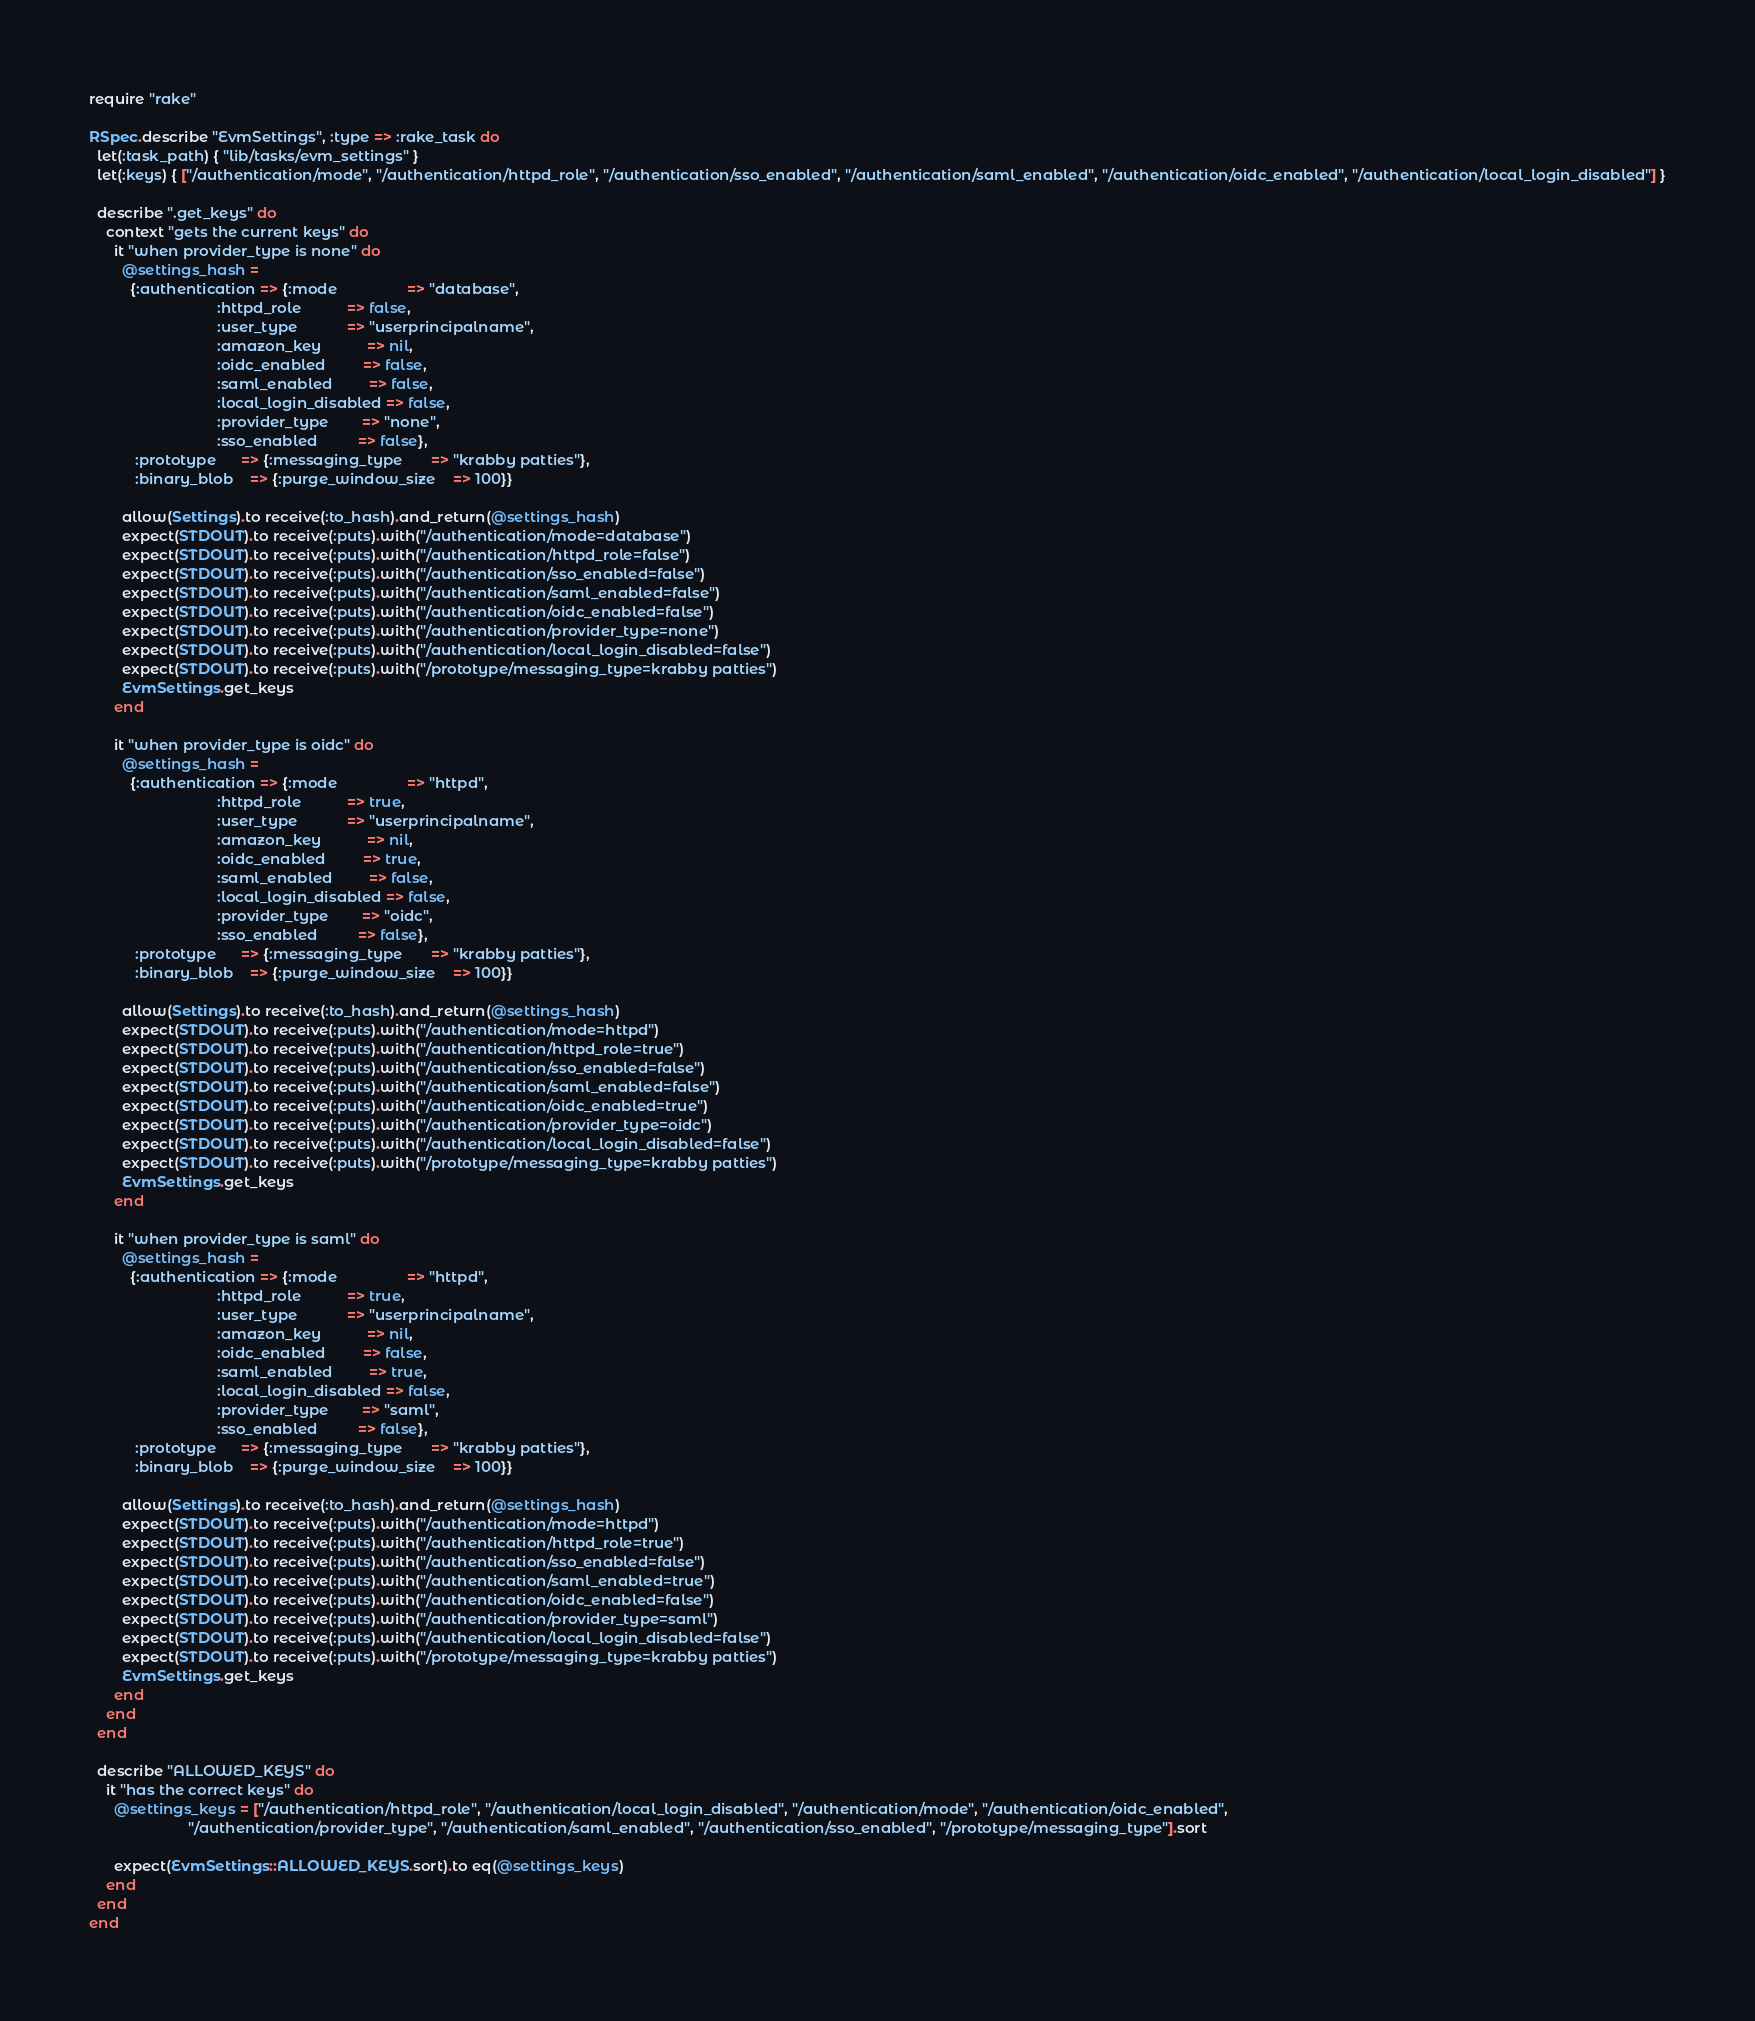Convert code to text. <code><loc_0><loc_0><loc_500><loc_500><_Ruby_>require "rake"

RSpec.describe "EvmSettings", :type => :rake_task do
  let(:task_path) { "lib/tasks/evm_settings" }
  let(:keys) { ["/authentication/mode", "/authentication/httpd_role", "/authentication/sso_enabled", "/authentication/saml_enabled", "/authentication/oidc_enabled", "/authentication/local_login_disabled"] }

  describe ".get_keys" do
    context "gets the current keys" do
      it "when provider_type is none" do
        @settings_hash =
          {:authentication => {:mode                 => "database",
                               :httpd_role           => false,
                               :user_type            => "userprincipalname",
                               :amazon_key           => nil,
                               :oidc_enabled         => false,
                               :saml_enabled         => false,
                               :local_login_disabled => false,
                               :provider_type        => "none",
                               :sso_enabled          => false},
           :prototype      => {:messaging_type       => "krabby patties"},
           :binary_blob    => {:purge_window_size    => 100}}

        allow(Settings).to receive(:to_hash).and_return(@settings_hash)
        expect(STDOUT).to receive(:puts).with("/authentication/mode=database")
        expect(STDOUT).to receive(:puts).with("/authentication/httpd_role=false")
        expect(STDOUT).to receive(:puts).with("/authentication/sso_enabled=false")
        expect(STDOUT).to receive(:puts).with("/authentication/saml_enabled=false")
        expect(STDOUT).to receive(:puts).with("/authentication/oidc_enabled=false")
        expect(STDOUT).to receive(:puts).with("/authentication/provider_type=none")
        expect(STDOUT).to receive(:puts).with("/authentication/local_login_disabled=false")
        expect(STDOUT).to receive(:puts).with("/prototype/messaging_type=krabby patties")
        EvmSettings.get_keys
      end

      it "when provider_type is oidc" do
        @settings_hash =
          {:authentication => {:mode                 => "httpd",
                               :httpd_role           => true,
                               :user_type            => "userprincipalname",
                               :amazon_key           => nil,
                               :oidc_enabled         => true,
                               :saml_enabled         => false,
                               :local_login_disabled => false,
                               :provider_type        => "oidc",
                               :sso_enabled          => false},
           :prototype      => {:messaging_type       => "krabby patties"},
           :binary_blob    => {:purge_window_size    => 100}}

        allow(Settings).to receive(:to_hash).and_return(@settings_hash)
        expect(STDOUT).to receive(:puts).with("/authentication/mode=httpd")
        expect(STDOUT).to receive(:puts).with("/authentication/httpd_role=true")
        expect(STDOUT).to receive(:puts).with("/authentication/sso_enabled=false")
        expect(STDOUT).to receive(:puts).with("/authentication/saml_enabled=false")
        expect(STDOUT).to receive(:puts).with("/authentication/oidc_enabled=true")
        expect(STDOUT).to receive(:puts).with("/authentication/provider_type=oidc")
        expect(STDOUT).to receive(:puts).with("/authentication/local_login_disabled=false")
        expect(STDOUT).to receive(:puts).with("/prototype/messaging_type=krabby patties")
        EvmSettings.get_keys
      end

      it "when provider_type is saml" do
        @settings_hash =
          {:authentication => {:mode                 => "httpd",
                               :httpd_role           => true,
                               :user_type            => "userprincipalname",
                               :amazon_key           => nil,
                               :oidc_enabled         => false,
                               :saml_enabled         => true,
                               :local_login_disabled => false,
                               :provider_type        => "saml",
                               :sso_enabled          => false},
           :prototype      => {:messaging_type       => "krabby patties"},
           :binary_blob    => {:purge_window_size    => 100}}

        allow(Settings).to receive(:to_hash).and_return(@settings_hash)
        expect(STDOUT).to receive(:puts).with("/authentication/mode=httpd")
        expect(STDOUT).to receive(:puts).with("/authentication/httpd_role=true")
        expect(STDOUT).to receive(:puts).with("/authentication/sso_enabled=false")
        expect(STDOUT).to receive(:puts).with("/authentication/saml_enabled=true")
        expect(STDOUT).to receive(:puts).with("/authentication/oidc_enabled=false")
        expect(STDOUT).to receive(:puts).with("/authentication/provider_type=saml")
        expect(STDOUT).to receive(:puts).with("/authentication/local_login_disabled=false")
        expect(STDOUT).to receive(:puts).with("/prototype/messaging_type=krabby patties")
        EvmSettings.get_keys
      end
    end
  end

  describe "ALLOWED_KEYS" do
    it "has the correct keys" do
      @settings_keys = ["/authentication/httpd_role", "/authentication/local_login_disabled", "/authentication/mode", "/authentication/oidc_enabled",
                        "/authentication/provider_type", "/authentication/saml_enabled", "/authentication/sso_enabled", "/prototype/messaging_type"].sort

      expect(EvmSettings::ALLOWED_KEYS.sort).to eq(@settings_keys)
    end
  end
end
</code> 